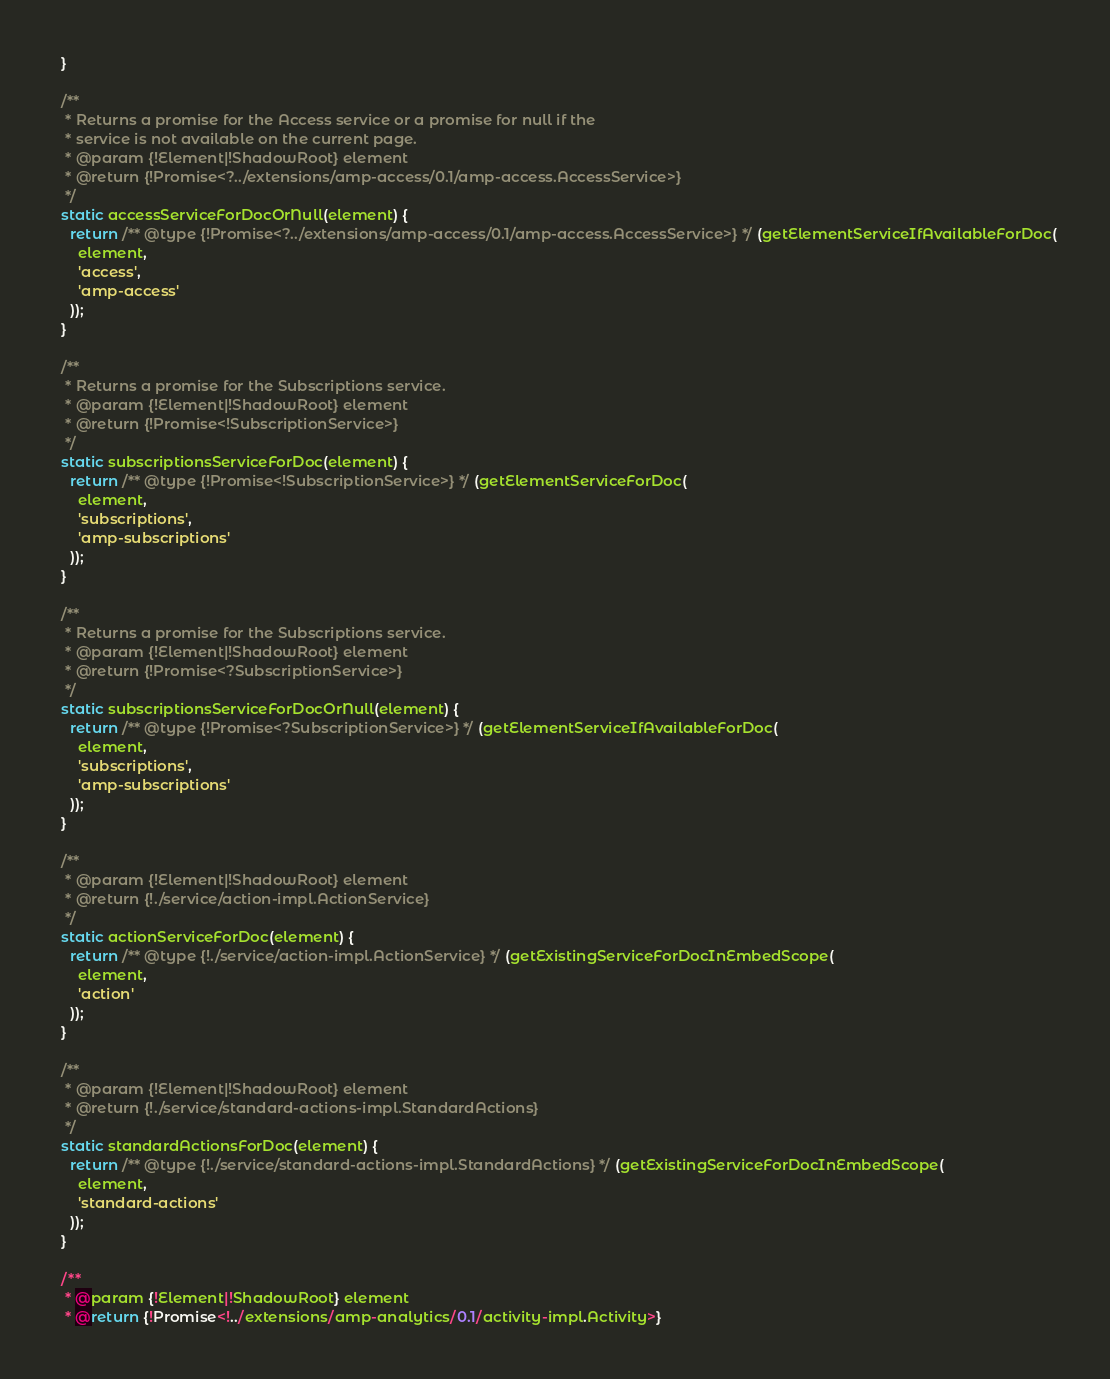<code> <loc_0><loc_0><loc_500><loc_500><_JavaScript_>  }

  /**
   * Returns a promise for the Access service or a promise for null if the
   * service is not available on the current page.
   * @param {!Element|!ShadowRoot} element
   * @return {!Promise<?../extensions/amp-access/0.1/amp-access.AccessService>}
   */
  static accessServiceForDocOrNull(element) {
    return /** @type {!Promise<?../extensions/amp-access/0.1/amp-access.AccessService>} */ (getElementServiceIfAvailableForDoc(
      element,
      'access',
      'amp-access'
    ));
  }

  /**
   * Returns a promise for the Subscriptions service.
   * @param {!Element|!ShadowRoot} element
   * @return {!Promise<!SubscriptionService>}
   */
  static subscriptionsServiceForDoc(element) {
    return /** @type {!Promise<!SubscriptionService>} */ (getElementServiceForDoc(
      element,
      'subscriptions',
      'amp-subscriptions'
    ));
  }

  /**
   * Returns a promise for the Subscriptions service.
   * @param {!Element|!ShadowRoot} element
   * @return {!Promise<?SubscriptionService>}
   */
  static subscriptionsServiceForDocOrNull(element) {
    return /** @type {!Promise<?SubscriptionService>} */ (getElementServiceIfAvailableForDoc(
      element,
      'subscriptions',
      'amp-subscriptions'
    ));
  }

  /**
   * @param {!Element|!ShadowRoot} element
   * @return {!./service/action-impl.ActionService}
   */
  static actionServiceForDoc(element) {
    return /** @type {!./service/action-impl.ActionService} */ (getExistingServiceForDocInEmbedScope(
      element,
      'action'
    ));
  }

  /**
   * @param {!Element|!ShadowRoot} element
   * @return {!./service/standard-actions-impl.StandardActions}
   */
  static standardActionsForDoc(element) {
    return /** @type {!./service/standard-actions-impl.StandardActions} */ (getExistingServiceForDocInEmbedScope(
      element,
      'standard-actions'
    ));
  }

  /**
   * @param {!Element|!ShadowRoot} element
   * @return {!Promise<!../extensions/amp-analytics/0.1/activity-impl.Activity>}</code> 